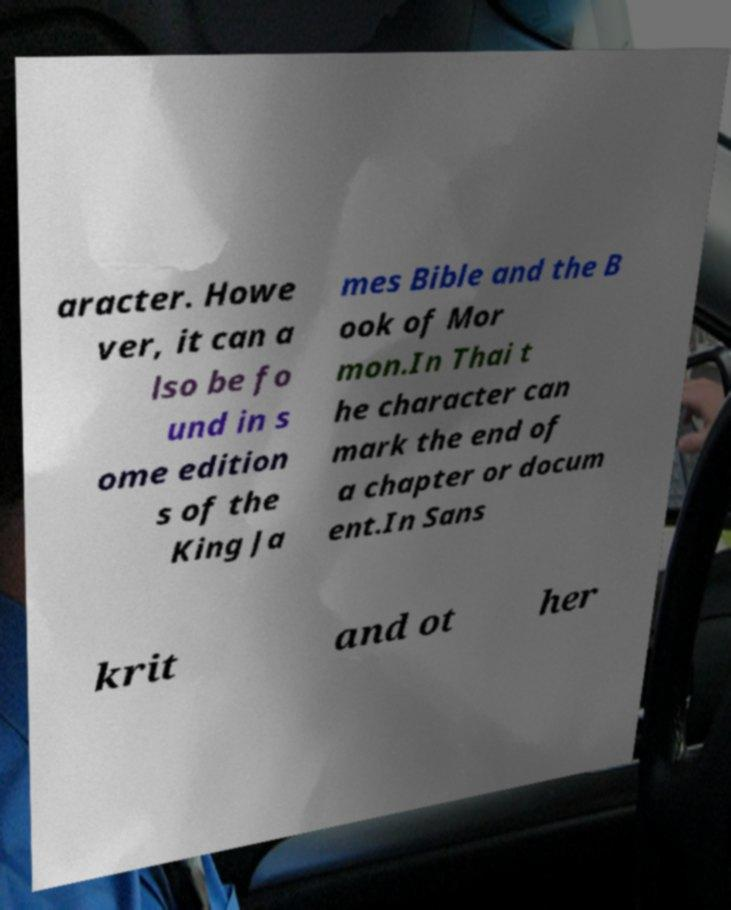Please identify and transcribe the text found in this image. aracter. Howe ver, it can a lso be fo und in s ome edition s of the King Ja mes Bible and the B ook of Mor mon.In Thai t he character can mark the end of a chapter or docum ent.In Sans krit and ot her 